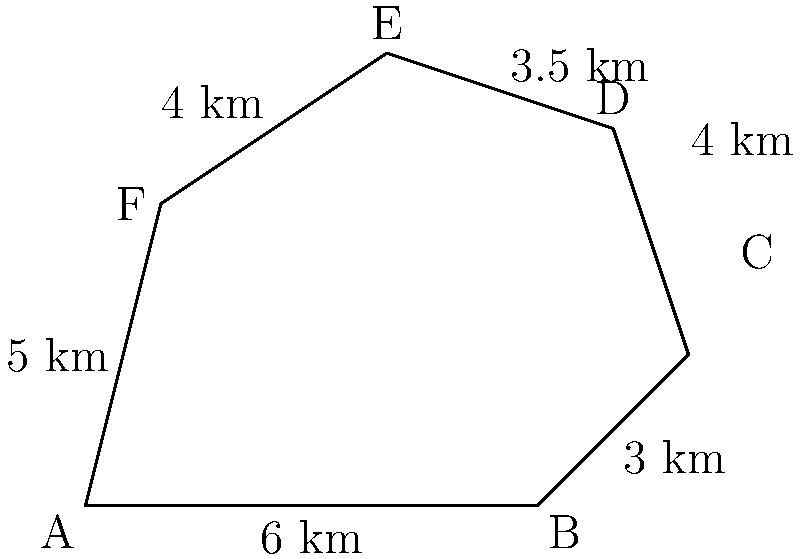A protected wetland area is represented by the irregular polygon ABCDEF shown above. Calculate the area of this wetland using the given side lengths and the coordinates of the vertices. Round your answer to the nearest square kilometer. To calculate the area of this irregular polygon, we can use the Shoelace formula (also known as the surveyor's formula). The steps are as follows:

1) First, we need to identify the coordinates of each vertex. From the diagram:
   A(0,0), B(6,0), C(8,2), D(7,5), E(4,6), F(1,4)

2) Apply the Shoelace formula:
   Area = $\frac{1}{2}|((x_1y_2 + x_2y_3 + ... + x_ny_1) - (y_1x_2 + y_2x_3 + ... + y_nx_1))|$

3) Substituting the coordinates:
   Area = $\frac{1}{2}|((0 \cdot 0 + 6 \cdot 2 + 8 \cdot 5 + 7 \cdot 6 + 4 \cdot 4 + 1 \cdot 0) - (0 \cdot 6 + 0 \cdot 8 + 2 \cdot 7 + 5 \cdot 4 + 6 \cdot 1 + 4 \cdot 0))|$

4) Simplify:
   Area = $\frac{1}{2}|(0 + 12 + 40 + 42 + 16 + 0) - (0 + 0 + 14 + 20 + 6 + 0)|$
   Area = $\frac{1}{2}|(110 - 40)|$
   Area = $\frac{1}{2}(70)$
   Area = 35 km²

Therefore, the area of the wetland is 35 square kilometers.
Answer: 35 km² 